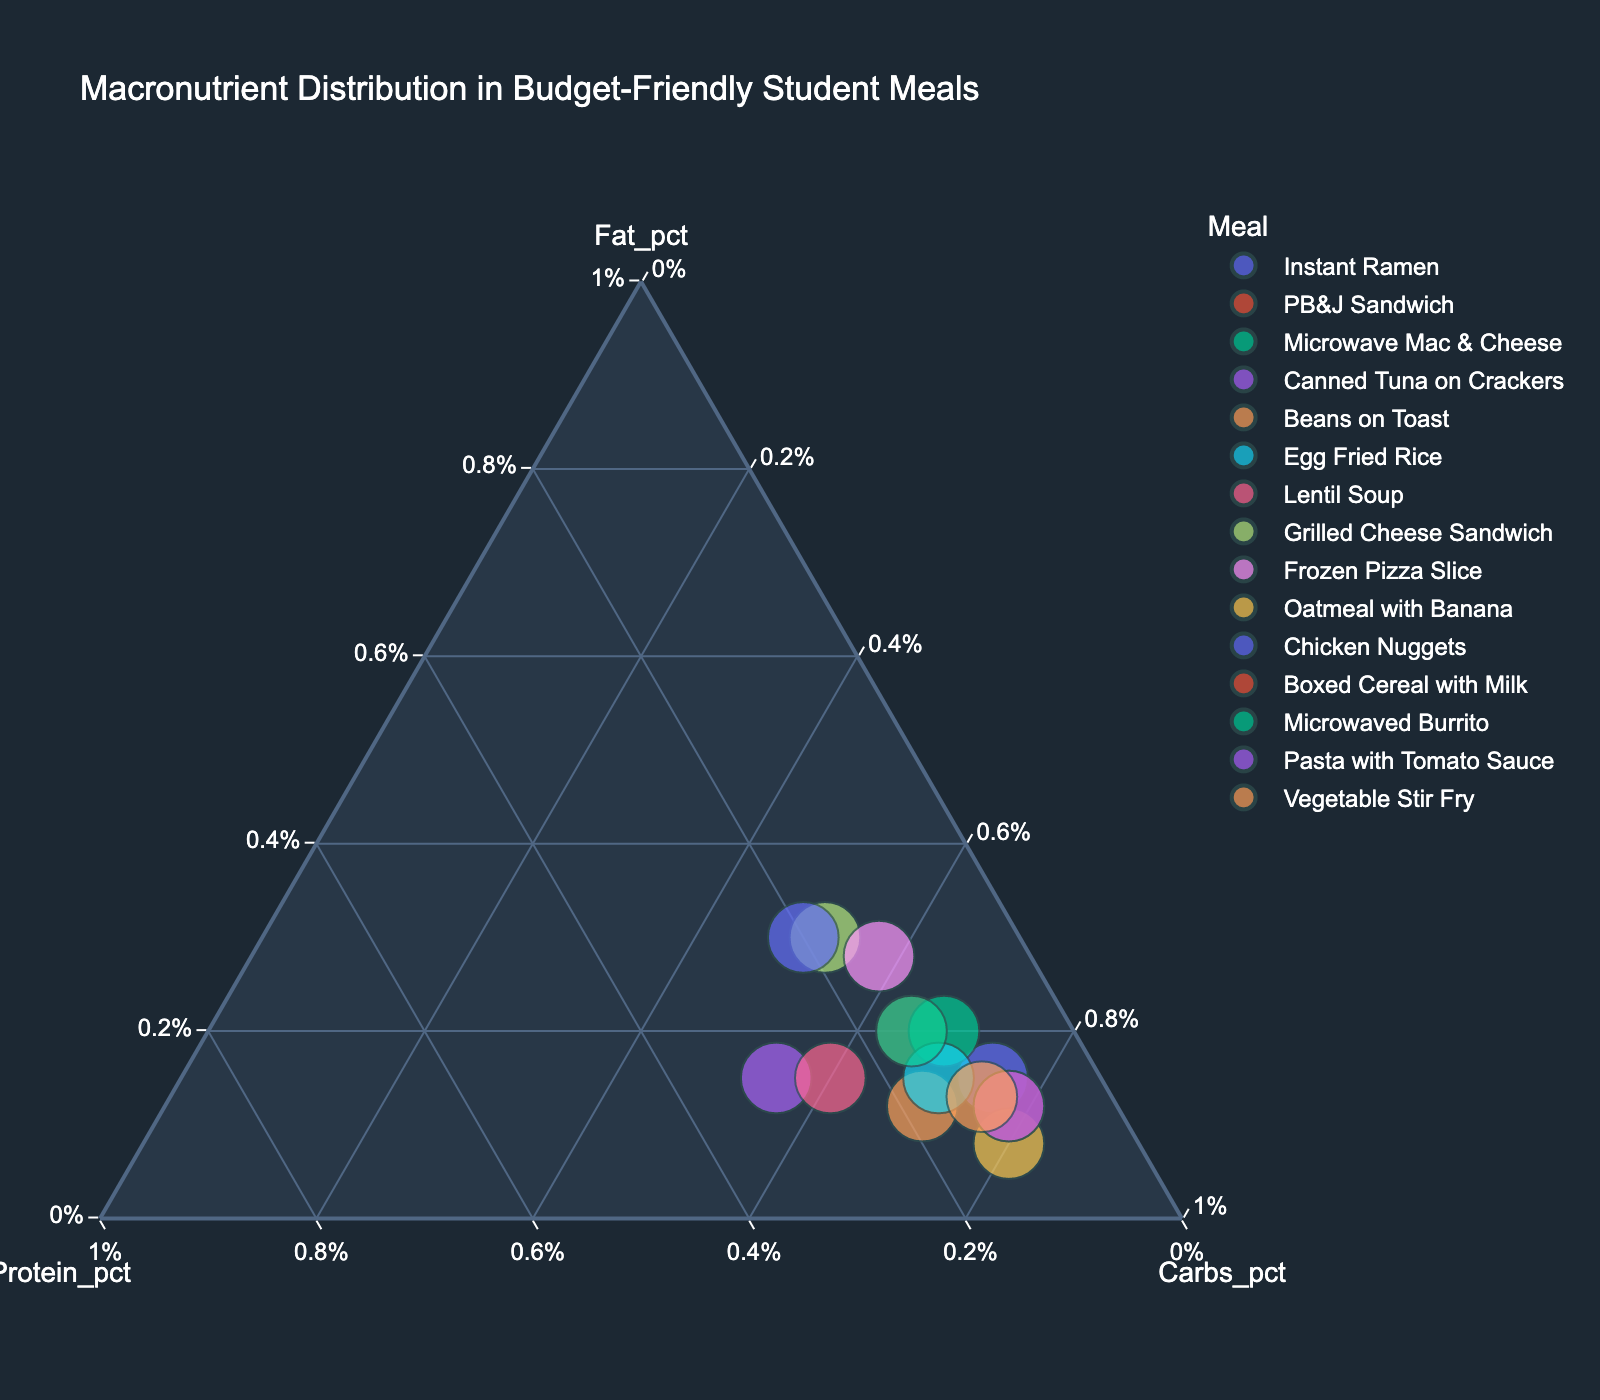What is the title of the figure? The title is displayed at the top of the figure, clearly stating what the plot is about.
Answer: Macronutrient Distribution in Budget-Friendly Student Meals How many meals are represented in the figure? Each data point corresponds to one meal. Count the number of data points in the figure.
Answer: 15 Which meal has the highest protein percentage? Find the data point located closest to the "100% Protein" corner of the ternary plot.
Answer: Canned Tuna on Crackers Between Instant Ramen and PB&J Sandwich, which meal has a higher fat percentage? Locate both data points and compare their distances to the "100% Fat" corner. The closer point has a higher fat percentage.
Answer: PB&J Sandwich Which meal has a higher carbohydrate percentage, Boxed Cereal with Milk or Pasta with Tomato Sauce? Locate the two data points and compare their distances to the "100% Carbs" corner. The closer point has a higher carbohydrate percentage.
Answer: Pasta with Tomato Sauce Can you identify a meal that has a balanced distribution of protein, carbs, and fat? Look for a data point near the center of the ternary plot, where the percentages of protein, carbs, and fat are nearly equal.
Answer: Vegetable Stir Fry Which meal has a larger overall size compared to others on the plot? Compare the sizes of the data points; a larger marker indicates a higher total macronutrient content.
Answer: Grilled Cheese Sandwich Is there a meal with a fat percentage higher than its protein and carbohydrate percentages? Identify any data point that is closest to the "100% Fat" corner and farther from the other two corners.
Answer: Grilled Cheese Sandwich How does the macronutrient distribution of Oatmeal with Banana compare to Microwave Mac & Cheese? Observe the position of both data points relative to each other and the three corners representing fat, protein, and carbs.
Answer: Oatmeal with Banana has higher carbs and lower fat Which meal has the highest carbohydrate percentage but lowest fat percentage? Find the data point closest to the "100% Carbs" corner and farthest from the "100% Fat" corner simultaneously.
Answer: Oatmeal with Banana 